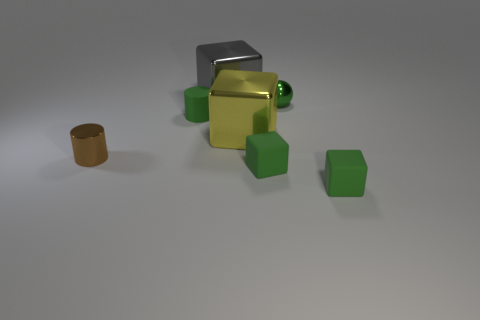Add 1 brown metallic things. How many objects exist? 8 Subtract all cubes. How many objects are left? 3 Add 3 gray objects. How many gray objects are left? 4 Add 7 yellow shiny objects. How many yellow shiny objects exist? 8 Subtract 0 blue blocks. How many objects are left? 7 Subtract all green cylinders. Subtract all metal cylinders. How many objects are left? 5 